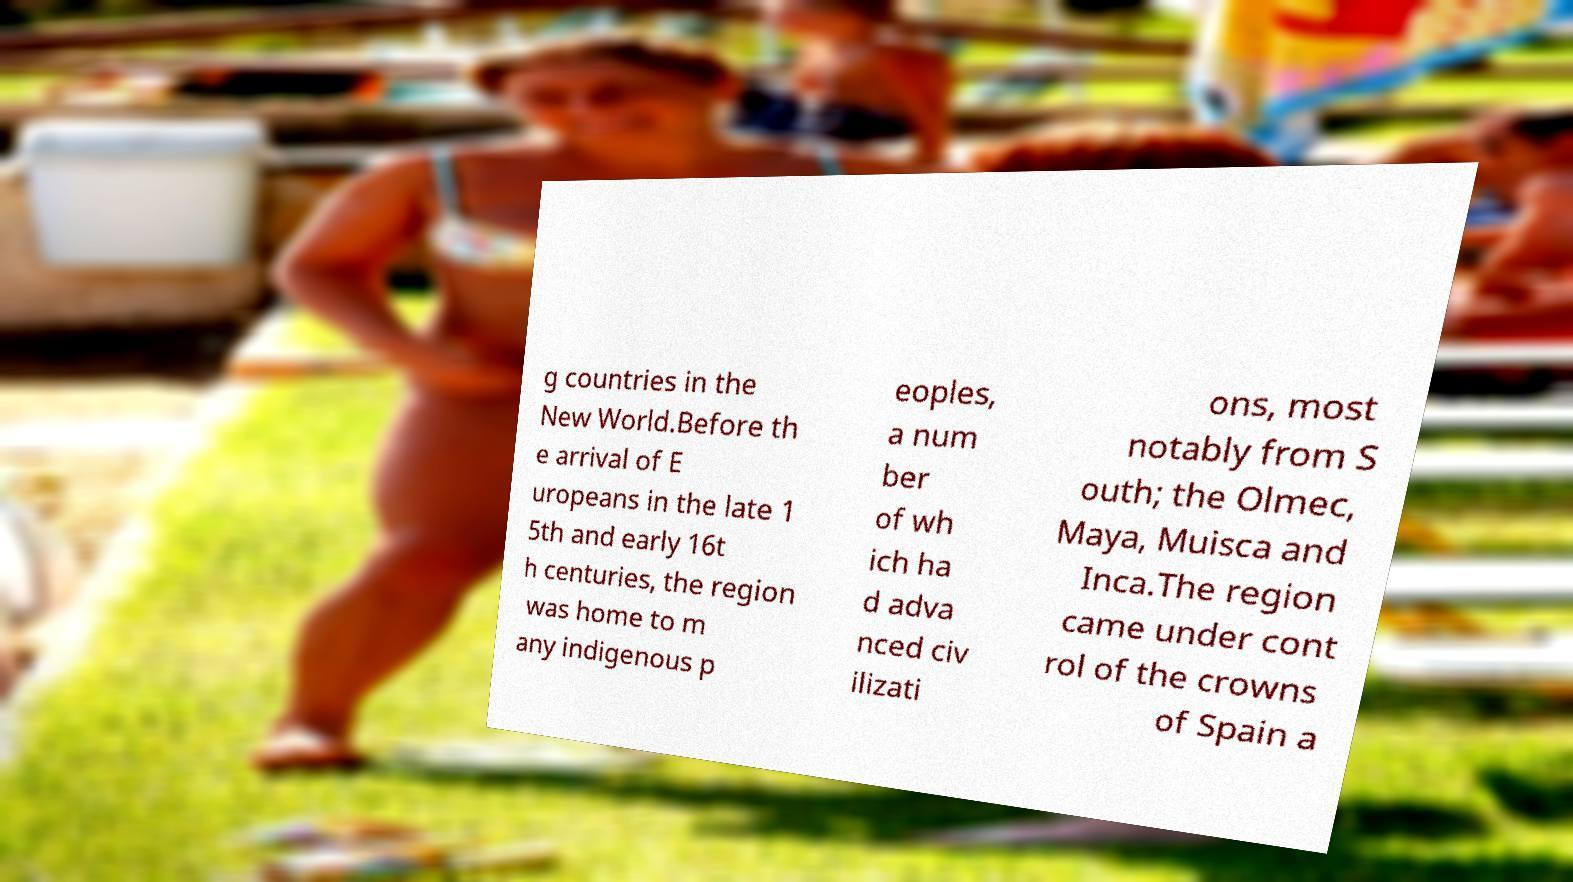Can you read and provide the text displayed in the image?This photo seems to have some interesting text. Can you extract and type it out for me? g countries in the New World.Before th e arrival of E uropeans in the late 1 5th and early 16t h centuries, the region was home to m any indigenous p eoples, a num ber of wh ich ha d adva nced civ ilizati ons, most notably from S outh; the Olmec, Maya, Muisca and Inca.The region came under cont rol of the crowns of Spain a 